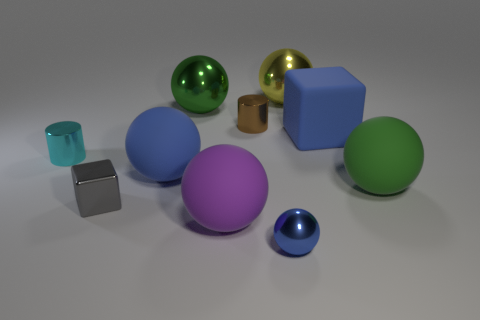Subtract all big purple rubber spheres. How many spheres are left? 5 Subtract all yellow balls. How many balls are left? 5 Subtract 6 spheres. How many spheres are left? 0 Subtract all tiny metallic cylinders. Subtract all yellow objects. How many objects are left? 7 Add 6 cylinders. How many cylinders are left? 8 Add 8 gray objects. How many gray objects exist? 9 Subtract 0 purple cylinders. How many objects are left? 10 Subtract all spheres. How many objects are left? 4 Subtract all yellow cylinders. Subtract all gray balls. How many cylinders are left? 2 Subtract all green cubes. How many blue spheres are left? 2 